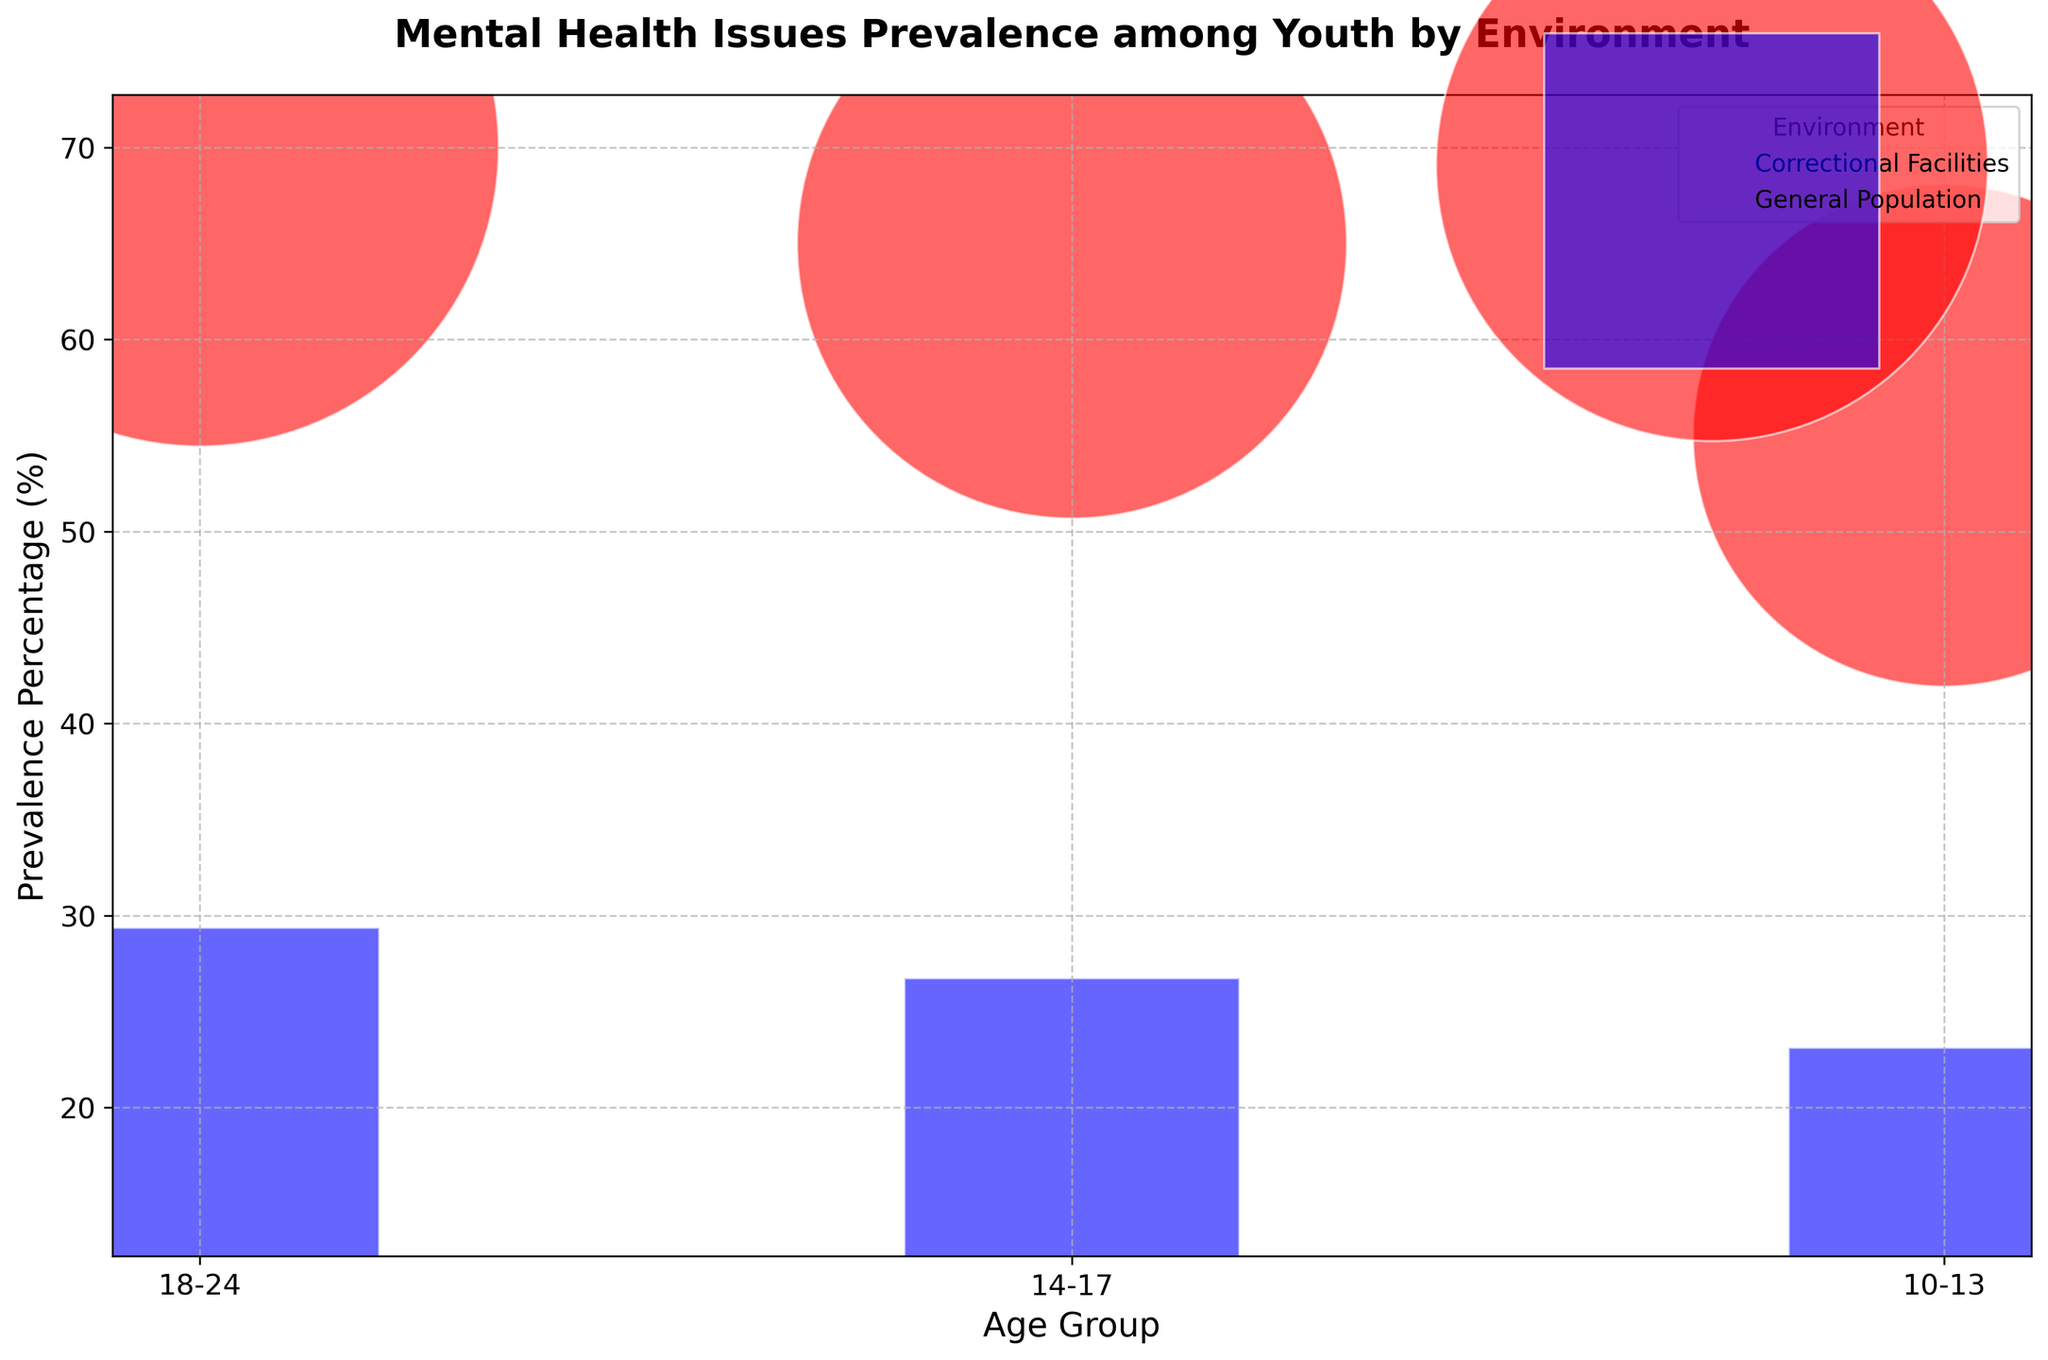What's the prevalence percentage of mental health issues among the 18-24 age group in correctional facilities? Look for the bubble representing the 18-24 age group in correctional facilities and note the prevalence percentage.
Answer: 70% Which age group in the general population has the least prevalence of mental health issues? Compare the prevalence percentages of all age groups within the general population and identify the smallest percentage.
Answer: 10-13 How much more prevalent are mental health issues among the 14-17 age group in correctional facilities compared to the same age group in the general population? Calculate the difference in prevalence percentage between the 14-17 age group in correctional facilities and the 14-17 age group in the general population.
Answer: 47% By how much does the prevalence percentage of mental health issues increase from the 10-13 age group to the 18-24 age group within correctional facilities? Subtract the prevalence percentage of the 10-13 age group from that of the 18-24 age group within correctional facilities.
Answer: 15% Which group has a larger bubble size, 14-17 age group in correctional facilities or the 14-17 age group in the general population? Compare the visual size of the bubbles representing the 14-17 age group in both environments.
Answer: 14-17 age group in correctional facilities Is the prevalence percentage for the 18-24 age group in general population greater than that of the 10-13 age group in correctional facilities? Compare the prevalence percentages of the 18-24 age group in the general population and the 10-13 age group in correctional facilities.
Answer: No Among the correctional facilities environment, which age group has the lowest prevalence of mental health issues? Identify the age group with the lowest prevalence percentage within the correctional facilities environment.
Answer: 10-13 Compare the bubble colors representing the environments in the figure. What is the color of the bubbles indicating correctional facilities? Identify the color used for the bubbles representing correctional facilities.
Answer: Red 